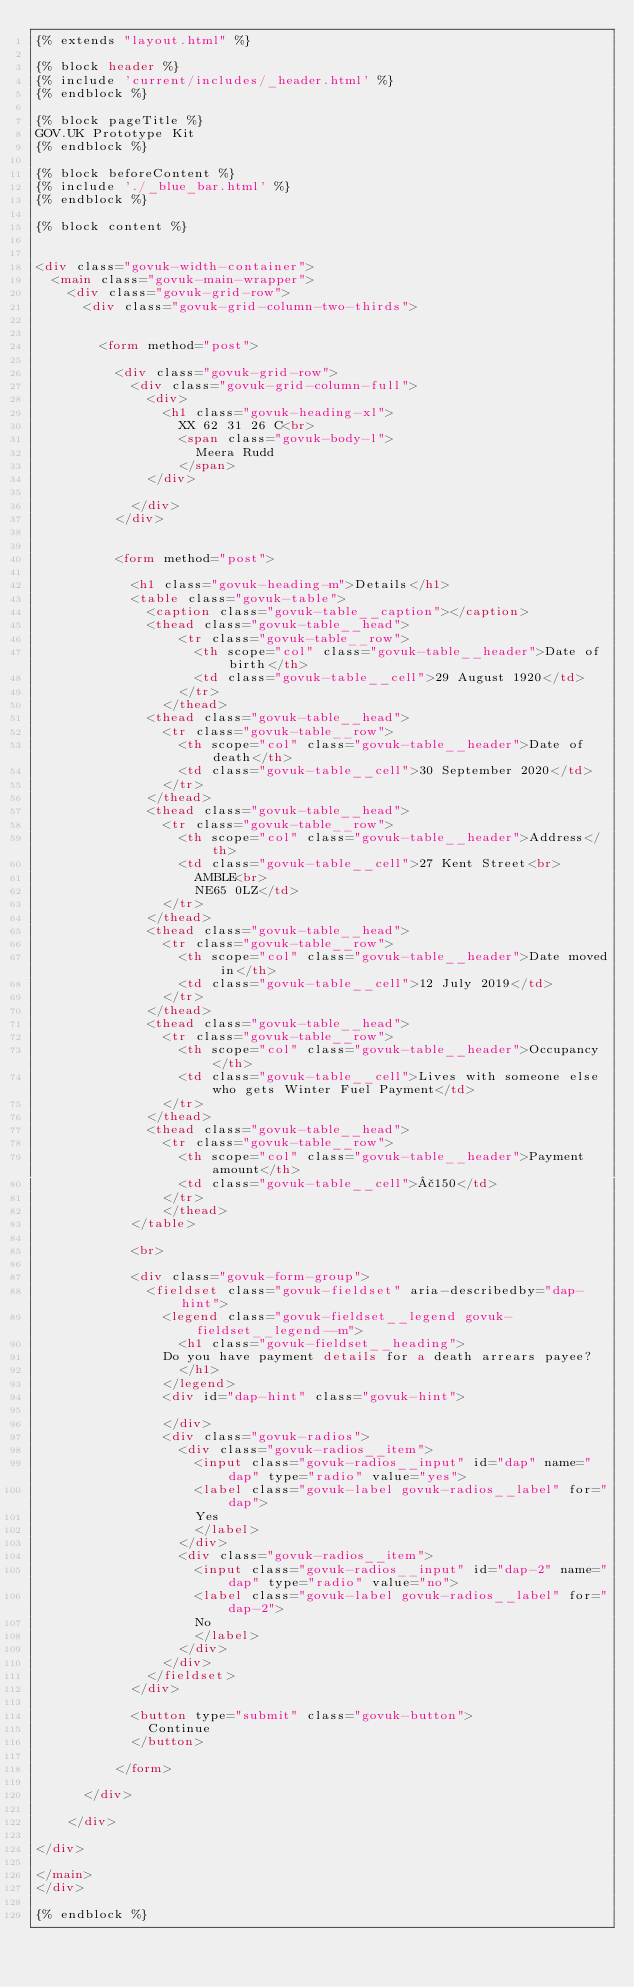Convert code to text. <code><loc_0><loc_0><loc_500><loc_500><_HTML_>{% extends "layout.html" %}

{% block header %}
{% include 'current/includes/_header.html' %}
{% endblock %}

{% block pageTitle %}
GOV.UK Prototype Kit
{% endblock %}

{% block beforeContent %}
{% include './_blue_bar.html' %}
{% endblock %}

{% block content %}


<div class="govuk-width-container">
  <main class="govuk-main-wrapper">
    <div class="govuk-grid-row">
      <div class="govuk-grid-column-two-thirds">


        <form method="post">

          <div class="govuk-grid-row">
            <div class="govuk-grid-column-full">
              <div>
                <h1 class="govuk-heading-xl">
                  XX 62 31 26 C<br>
                  <span class="govuk-body-l">
                    Meera Rudd
                  </span>
              </div>

            </div>
          </div>


          <form method="post">

            <h1 class="govuk-heading-m">Details</h1>
            <table class="govuk-table">
              <caption class="govuk-table__caption"></caption>
              <thead class="govuk-table__head">
                  <tr class="govuk-table__row">
                    <th scope="col" class="govuk-table__header">Date of birth</th>
                    <td class="govuk-table__cell">29 August 1920</td>
                  </tr>
                </thead>
              <thead class="govuk-table__head">
                <tr class="govuk-table__row">
                  <th scope="col" class="govuk-table__header">Date of death</th>
                  <td class="govuk-table__cell">30 September 2020</td>
                </tr>
              </thead>
              <thead class="govuk-table__head">
                <tr class="govuk-table__row">
                  <th scope="col" class="govuk-table__header">Address</th>
                  <td class="govuk-table__cell">27 Kent Street<br>
                    AMBLE<br>
                    NE65 0LZ</td>
                </tr>
              </thead>
              <thead class="govuk-table__head">
                <tr class="govuk-table__row">
                  <th scope="col" class="govuk-table__header">Date moved in</th>
                  <td class="govuk-table__cell">12 July 2019</td>
                </tr>
              </thead>
              <thead class="govuk-table__head">
                <tr class="govuk-table__row">
                  <th scope="col" class="govuk-table__header">Occupancy</th>
                  <td class="govuk-table__cell">Lives with someone else who gets Winter Fuel Payment</td>
                </tr>
              </thead>
              <thead class="govuk-table__head">
                <tr class="govuk-table__row">
                  <th scope="col" class="govuk-table__header">Payment amount</th>
                  <td class="govuk-table__cell">£150</td>
                </tr>
                </thead>
            </table>

            <br>

            <div class="govuk-form-group">
              <fieldset class="govuk-fieldset" aria-describedby="dap-hint">
                <legend class="govuk-fieldset__legend govuk-fieldset__legend--m">
                  <h1 class="govuk-fieldset__heading">
                Do you have payment details for a death arrears payee?
                  </h1>
                </legend>
                <div id="dap-hint" class="govuk-hint">

                </div>
                <div class="govuk-radios">
                  <div class="govuk-radios__item">
                    <input class="govuk-radios__input" id="dap" name="dap" type="radio" value="yes">
                    <label class="govuk-label govuk-radios__label" for="dap">
                    Yes
                    </label>
                  </div>
                  <div class="govuk-radios__item">
                    <input class="govuk-radios__input" id="dap-2" name="dap" type="radio" value="no">
                    <label class="govuk-label govuk-radios__label" for="dap-2">
                    No
                    </label>
                  </div>
                </div>
              </fieldset>
            </div>

            <button type="submit" class="govuk-button">
              Continue
            </button>

          </form>

      </div>

    </div>

</div>

</main>
</div>

{% endblock %}
</code> 